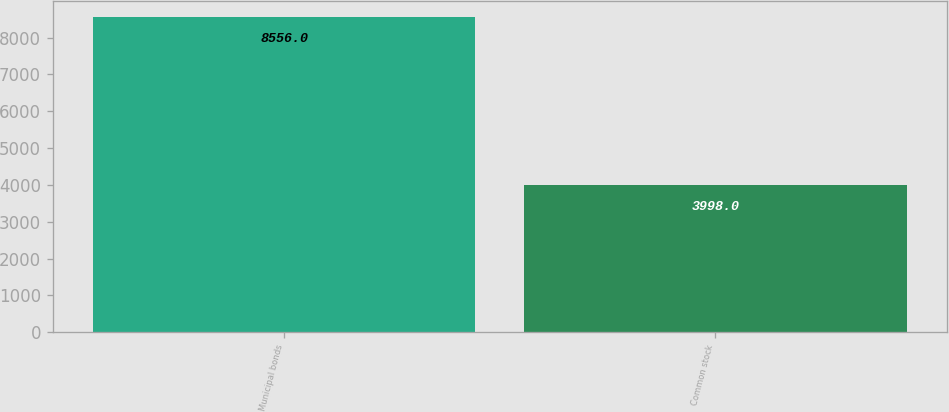<chart> <loc_0><loc_0><loc_500><loc_500><bar_chart><fcel>Municipal bonds<fcel>Common stock<nl><fcel>8556<fcel>3998<nl></chart> 